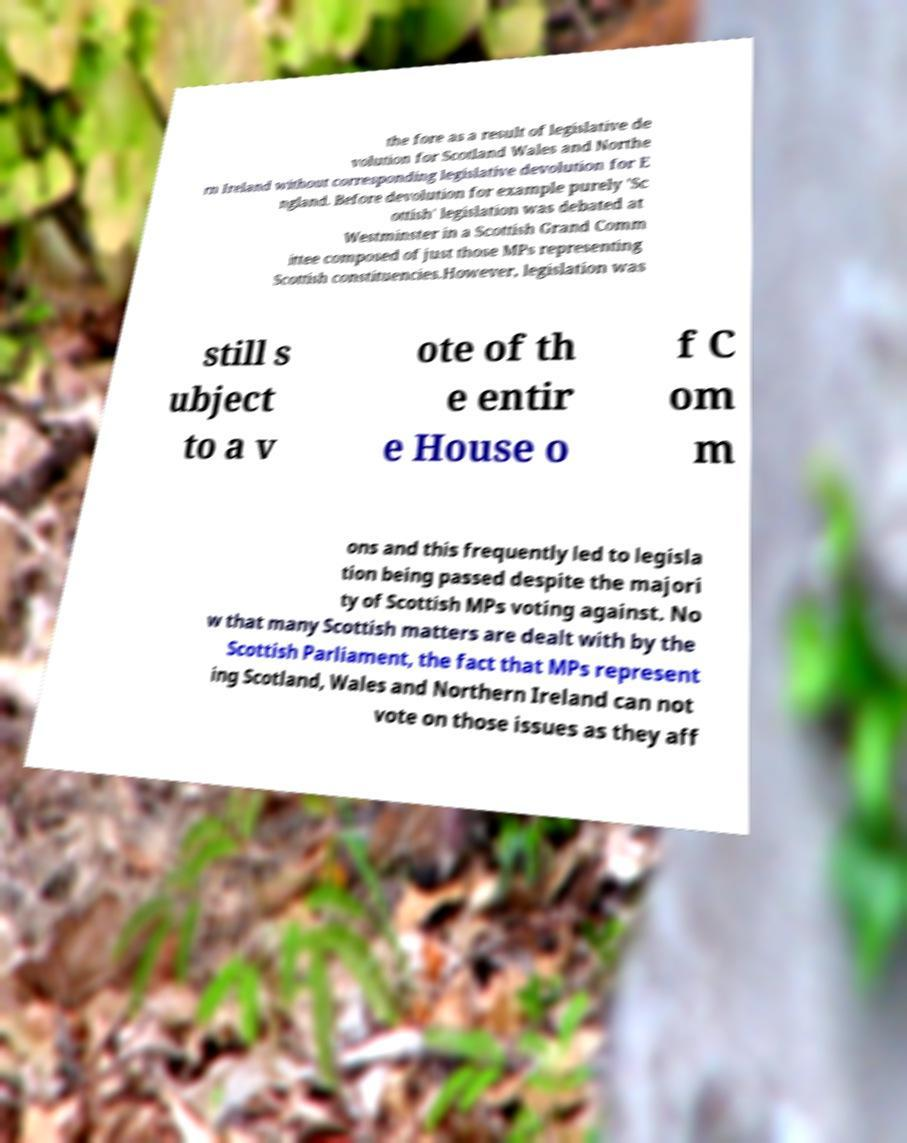There's text embedded in this image that I need extracted. Can you transcribe it verbatim? the fore as a result of legislative de volution for Scotland Wales and Northe rn Ireland without corresponding legislative devolution for E ngland. Before devolution for example purely 'Sc ottish' legislation was debated at Westminster in a Scottish Grand Comm ittee composed of just those MPs representing Scottish constituencies.However, legislation was still s ubject to a v ote of th e entir e House o f C om m ons and this frequently led to legisla tion being passed despite the majori ty of Scottish MPs voting against. No w that many Scottish matters are dealt with by the Scottish Parliament, the fact that MPs represent ing Scotland, Wales and Northern Ireland can not vote on those issues as they aff 